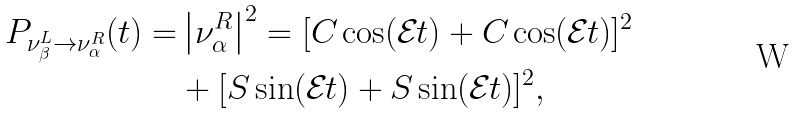Convert formula to latex. <formula><loc_0><loc_0><loc_500><loc_500>P _ { \nu _ { \beta } ^ { L } \to \nu _ { \alpha } ^ { R } } ( t ) = & \left | \nu _ { \alpha } ^ { R } \right | ^ { 2 } = [ C _ { } \cos ( \mathcal { E } _ { } t ) + C _ { } \cos ( \mathcal { E } _ { } t ) ] ^ { 2 } \\ & + [ S _ { } \sin ( \mathcal { E } _ { } t ) + S _ { } \sin ( \mathcal { E } _ { } t ) ] ^ { 2 } ,</formula> 